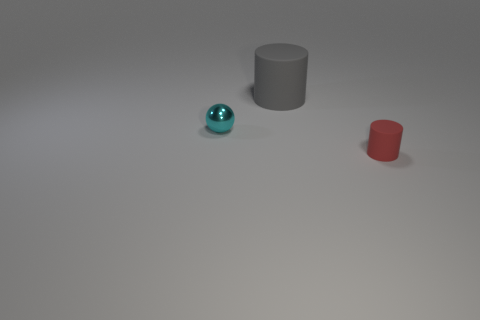Is there anything else that is the same size as the gray thing?
Keep it short and to the point. No. Is there any other thing that is the same material as the tiny cyan sphere?
Your response must be concise. No. Is the number of tiny cylinders that are right of the tiny sphere less than the number of gray matte cylinders that are left of the large cylinder?
Offer a terse response. No. There is a cylinder that is in front of the cylinder behind the cyan thing; what number of tiny red rubber cylinders are on the left side of it?
Make the answer very short. 0. Is the tiny shiny ball the same color as the small matte thing?
Give a very brief answer. No. Are there any big matte things of the same color as the sphere?
Give a very brief answer. No. The other object that is the same size as the red matte object is what color?
Your answer should be compact. Cyan. Are there any other tiny metal things of the same shape as the red object?
Offer a terse response. No. There is a rubber cylinder behind the cylinder that is in front of the cyan metal object; is there a matte cylinder in front of it?
Provide a succinct answer. Yes. There is a object that is the same size as the red cylinder; what shape is it?
Keep it short and to the point. Sphere. 